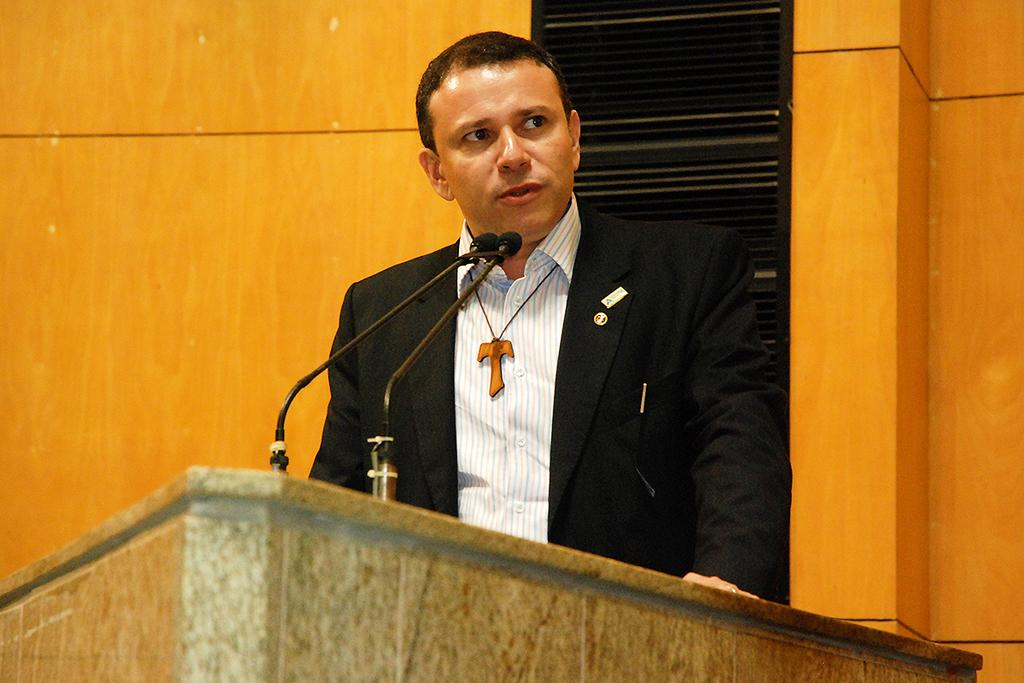Who is the main subject in the image? There is a man in the center of the image. What is the man doing in the image? The man is standing in front of a podium and talking. What objects are on the podium? There are microphones on the podium. What can be seen in the background of the image? There is a wall in the background of the image. What type of crate is being used by the man to make his statement in the image? There is no crate present in the image; the man is standing in front of a podium with microphones. 